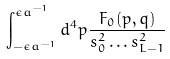<formula> <loc_0><loc_0><loc_500><loc_500>\int _ { - \epsilon a ^ { - 1 } } ^ { \epsilon a ^ { - 1 } } d ^ { 4 } p \frac { F _ { 0 } ( p , q ) } { s _ { 0 } ^ { 2 } \dots s _ { L - 1 } ^ { 2 } }</formula> 